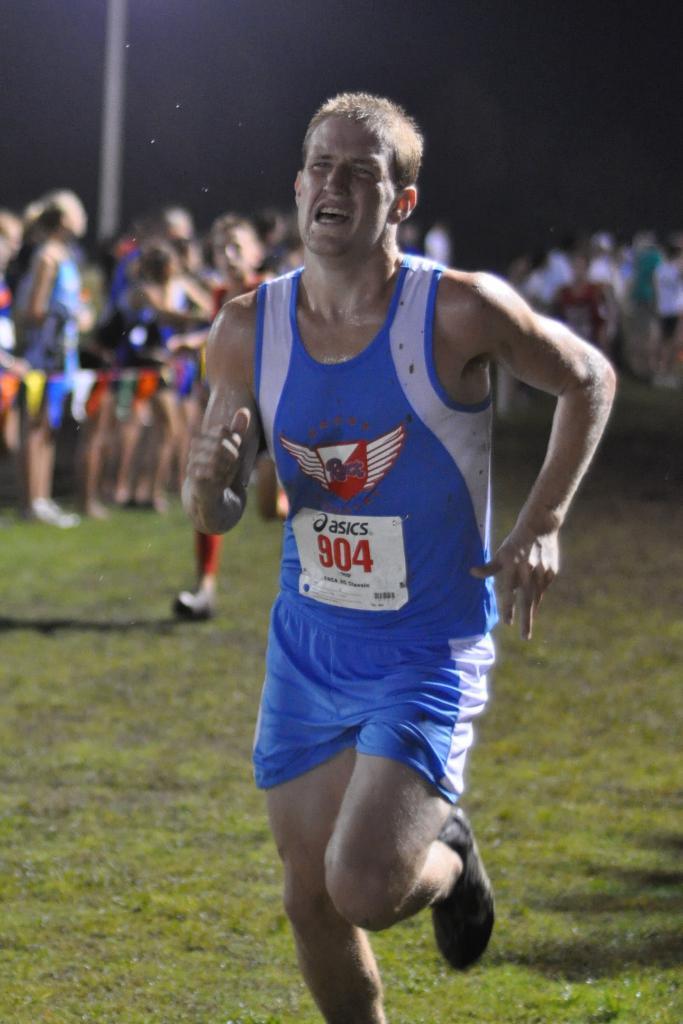Is asics above his number?
Your response must be concise. Yes. 